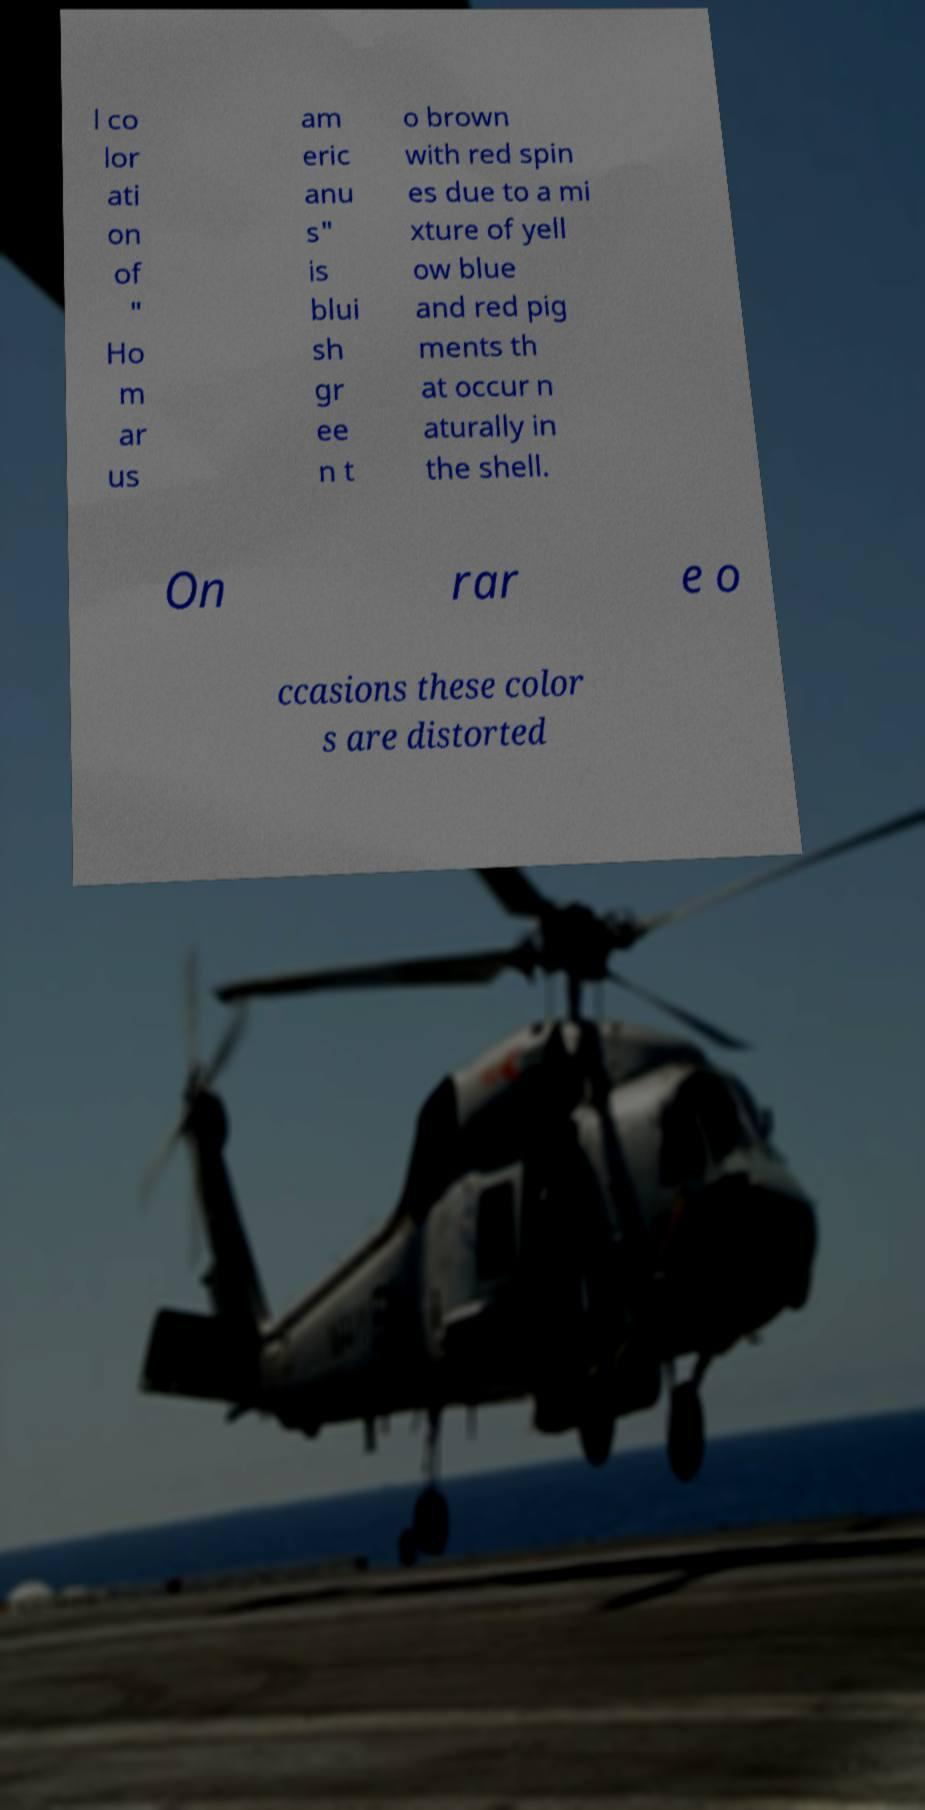Can you read and provide the text displayed in the image?This photo seems to have some interesting text. Can you extract and type it out for me? l co lor ati on of " Ho m ar us am eric anu s" is blui sh gr ee n t o brown with red spin es due to a mi xture of yell ow blue and red pig ments th at occur n aturally in the shell. On rar e o ccasions these color s are distorted 